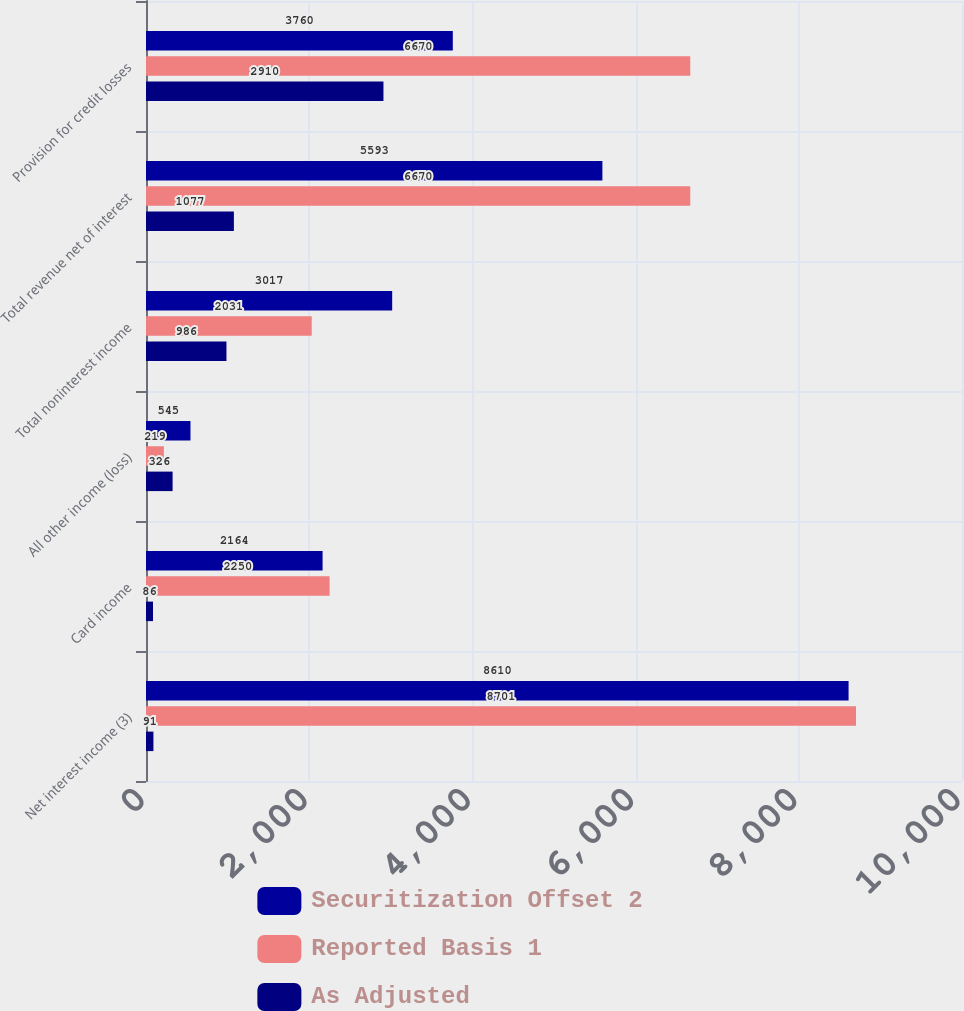<chart> <loc_0><loc_0><loc_500><loc_500><stacked_bar_chart><ecel><fcel>Net interest income (3)<fcel>Card income<fcel>All other income (loss)<fcel>Total noninterest income<fcel>Total revenue net of interest<fcel>Provision for credit losses<nl><fcel>Securitization Offset 2<fcel>8610<fcel>2164<fcel>545<fcel>3017<fcel>5593<fcel>3760<nl><fcel>Reported Basis 1<fcel>8701<fcel>2250<fcel>219<fcel>2031<fcel>6670<fcel>6670<nl><fcel>As Adjusted<fcel>91<fcel>86<fcel>326<fcel>986<fcel>1077<fcel>2910<nl></chart> 